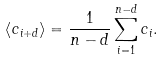<formula> <loc_0><loc_0><loc_500><loc_500>\left < c _ { i + d } \right > = \frac { 1 } { n - d } \sum _ { i = 1 } ^ { n - d } c _ { i } .</formula> 